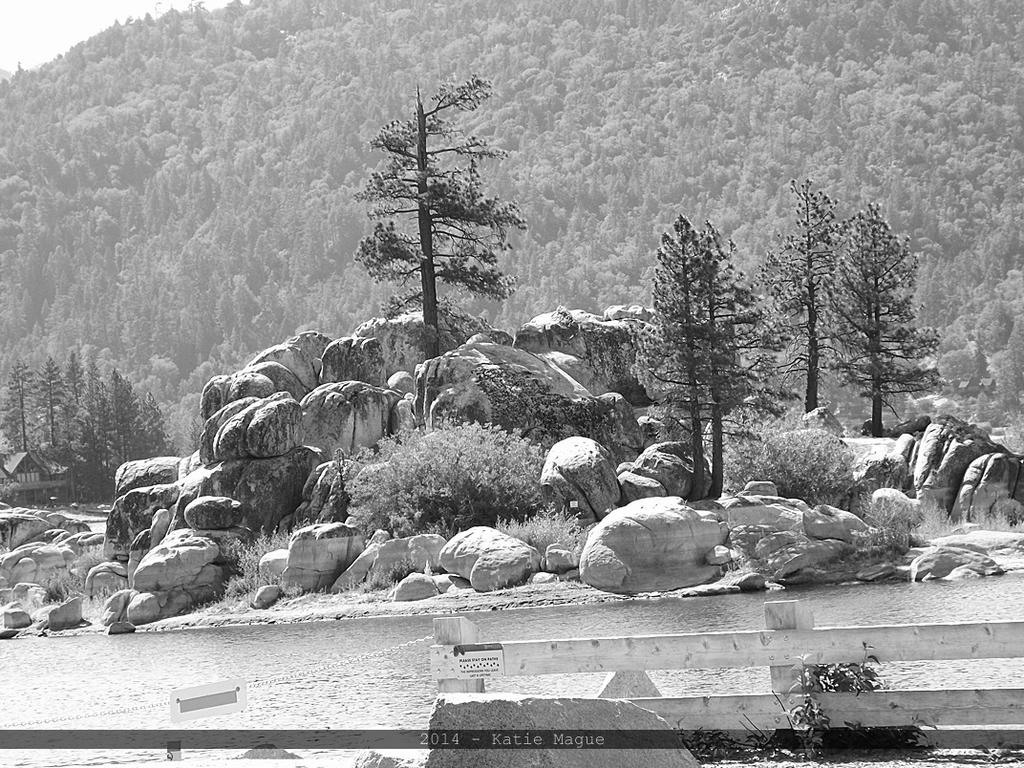What type of barrier can be seen in the image? There is a fence in the image. What type of vegetation is present in the image? There is grass, plants, trees, and possibly a lake in the image. What type of terrain is visible in the image? There are rocks, stones, and mountains visible in the image. What is the background of the image? The sky is visible in the image. What else can be seen in the image? There is text in the image. What time of day is it in the image? The time of day cannot be determined from the image alone, as there are no specific indicators of morning or any other time of day. What type of tool is used to cut the bean in the image? There is no bean or cutting tool present in the image. 